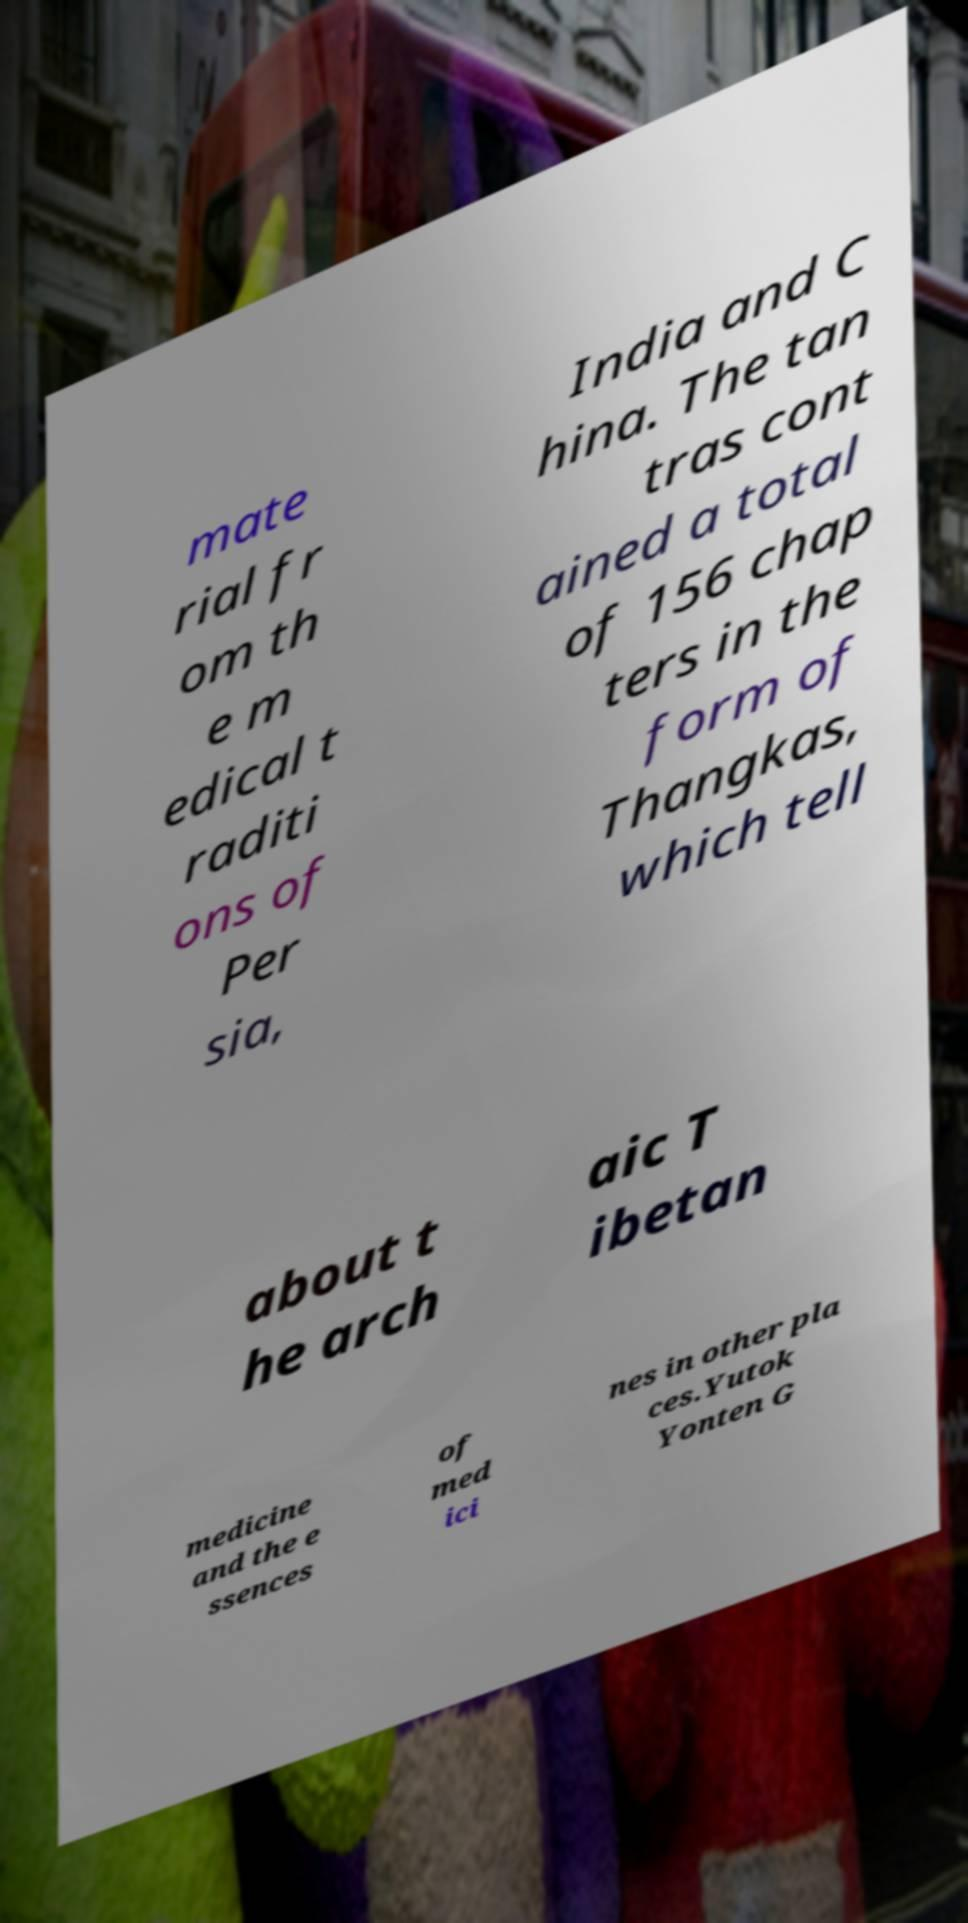Could you extract and type out the text from this image? mate rial fr om th e m edical t raditi ons of Per sia, India and C hina. The tan tras cont ained a total of 156 chap ters in the form of Thangkas, which tell about t he arch aic T ibetan medicine and the e ssences of med ici nes in other pla ces.Yutok Yonten G 